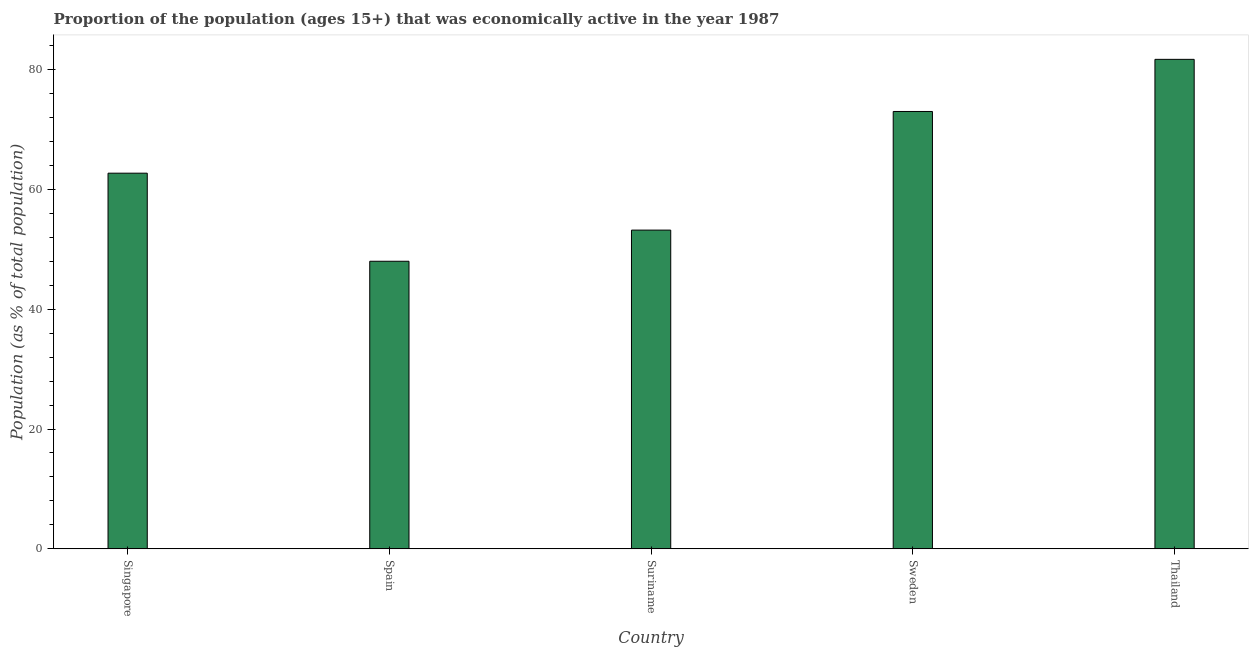Does the graph contain any zero values?
Offer a very short reply. No. Does the graph contain grids?
Offer a terse response. No. What is the title of the graph?
Ensure brevity in your answer.  Proportion of the population (ages 15+) that was economically active in the year 1987. What is the label or title of the Y-axis?
Your answer should be very brief. Population (as % of total population). Across all countries, what is the maximum percentage of economically active population?
Your answer should be compact. 81.7. Across all countries, what is the minimum percentage of economically active population?
Offer a very short reply. 48. In which country was the percentage of economically active population maximum?
Provide a succinct answer. Thailand. What is the sum of the percentage of economically active population?
Ensure brevity in your answer.  318.6. What is the difference between the percentage of economically active population in Singapore and Thailand?
Provide a short and direct response. -19. What is the average percentage of economically active population per country?
Your answer should be very brief. 63.72. What is the median percentage of economically active population?
Keep it short and to the point. 62.7. What is the ratio of the percentage of economically active population in Sweden to that in Thailand?
Your answer should be very brief. 0.89. Is the percentage of economically active population in Singapore less than that in Thailand?
Keep it short and to the point. Yes. Is the difference between the percentage of economically active population in Spain and Suriname greater than the difference between any two countries?
Provide a short and direct response. No. What is the difference between the highest and the lowest percentage of economically active population?
Ensure brevity in your answer.  33.7. What is the difference between two consecutive major ticks on the Y-axis?
Offer a terse response. 20. Are the values on the major ticks of Y-axis written in scientific E-notation?
Give a very brief answer. No. What is the Population (as % of total population) in Singapore?
Provide a short and direct response. 62.7. What is the Population (as % of total population) of Spain?
Give a very brief answer. 48. What is the Population (as % of total population) in Suriname?
Give a very brief answer. 53.2. What is the Population (as % of total population) of Sweden?
Offer a terse response. 73. What is the Population (as % of total population) of Thailand?
Offer a very short reply. 81.7. What is the difference between the Population (as % of total population) in Singapore and Spain?
Your response must be concise. 14.7. What is the difference between the Population (as % of total population) in Singapore and Sweden?
Give a very brief answer. -10.3. What is the difference between the Population (as % of total population) in Spain and Suriname?
Your answer should be very brief. -5.2. What is the difference between the Population (as % of total population) in Spain and Sweden?
Keep it short and to the point. -25. What is the difference between the Population (as % of total population) in Spain and Thailand?
Keep it short and to the point. -33.7. What is the difference between the Population (as % of total population) in Suriname and Sweden?
Offer a terse response. -19.8. What is the difference between the Population (as % of total population) in Suriname and Thailand?
Offer a very short reply. -28.5. What is the ratio of the Population (as % of total population) in Singapore to that in Spain?
Offer a terse response. 1.31. What is the ratio of the Population (as % of total population) in Singapore to that in Suriname?
Provide a short and direct response. 1.18. What is the ratio of the Population (as % of total population) in Singapore to that in Sweden?
Offer a very short reply. 0.86. What is the ratio of the Population (as % of total population) in Singapore to that in Thailand?
Provide a succinct answer. 0.77. What is the ratio of the Population (as % of total population) in Spain to that in Suriname?
Offer a very short reply. 0.9. What is the ratio of the Population (as % of total population) in Spain to that in Sweden?
Offer a terse response. 0.66. What is the ratio of the Population (as % of total population) in Spain to that in Thailand?
Offer a terse response. 0.59. What is the ratio of the Population (as % of total population) in Suriname to that in Sweden?
Ensure brevity in your answer.  0.73. What is the ratio of the Population (as % of total population) in Suriname to that in Thailand?
Offer a terse response. 0.65. What is the ratio of the Population (as % of total population) in Sweden to that in Thailand?
Give a very brief answer. 0.89. 